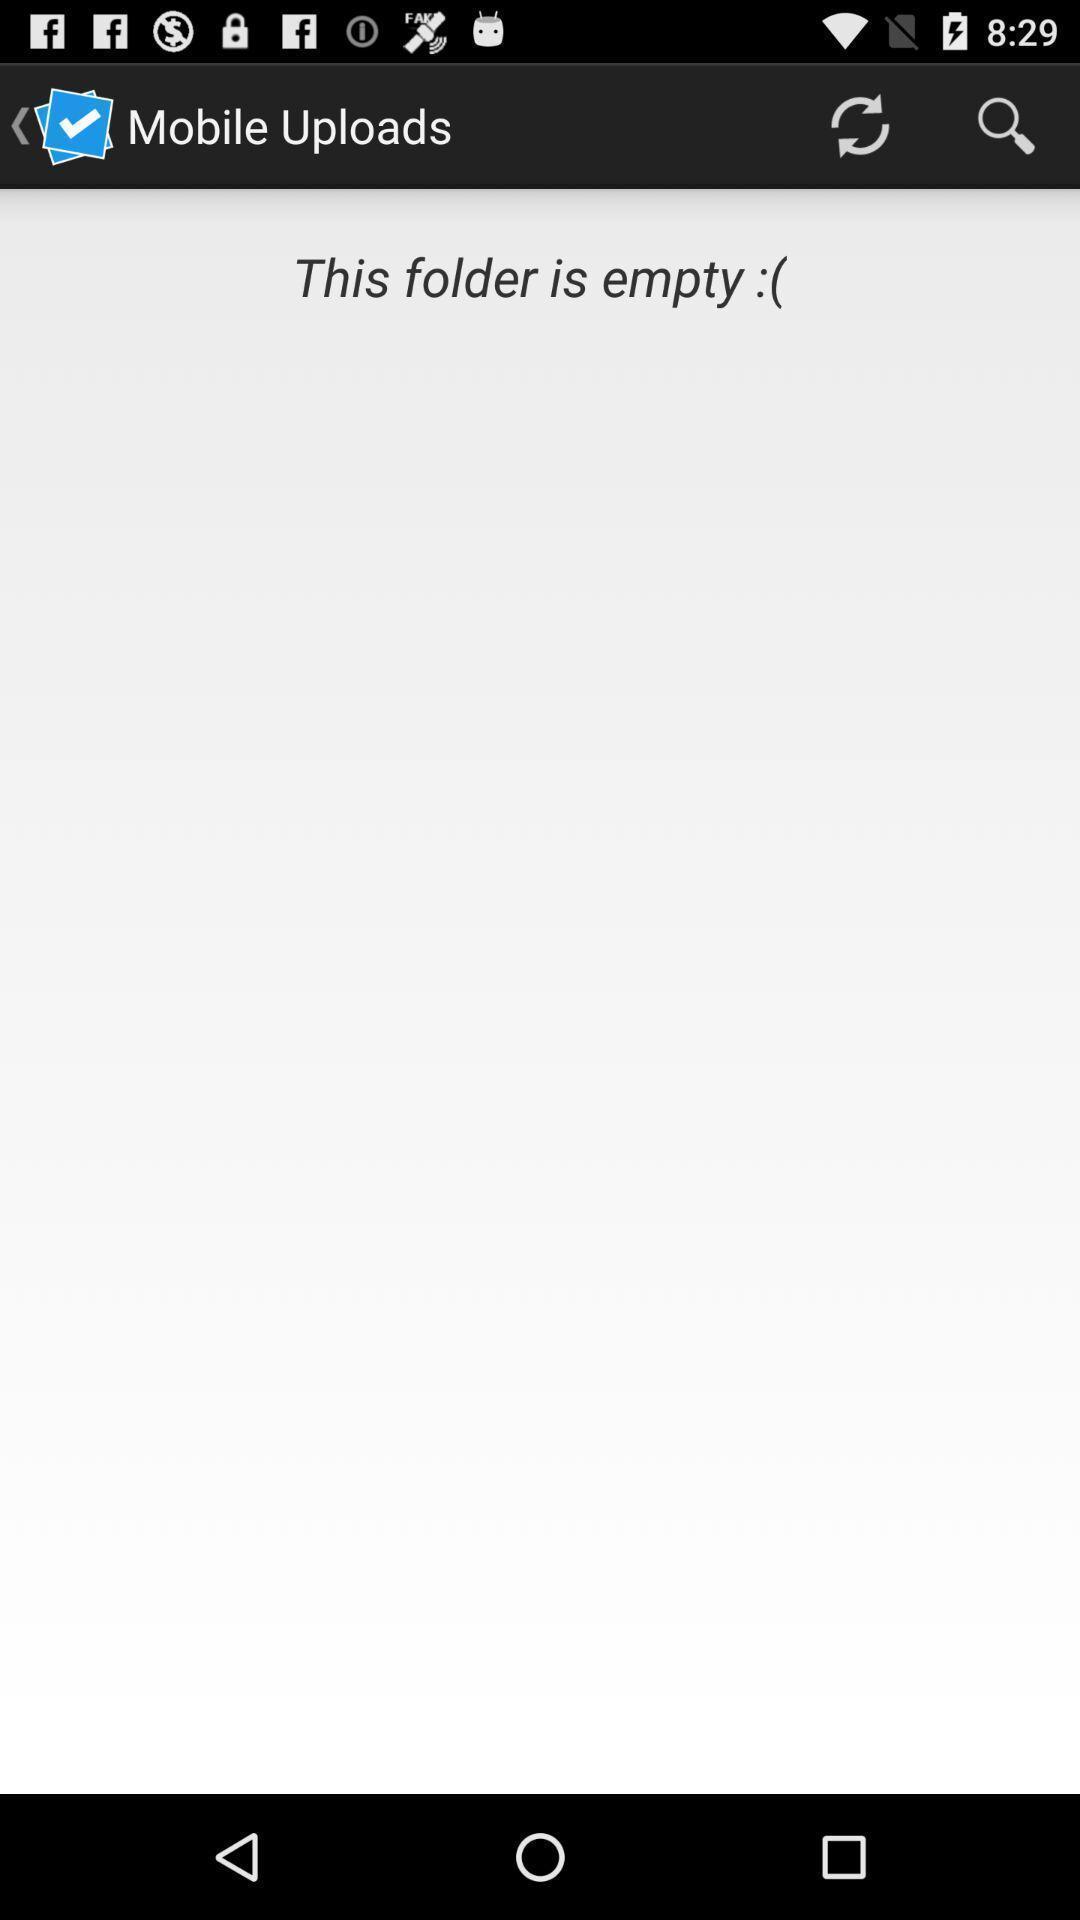Describe the key features of this screenshot. Screen displaying the page of mobile uploads. 